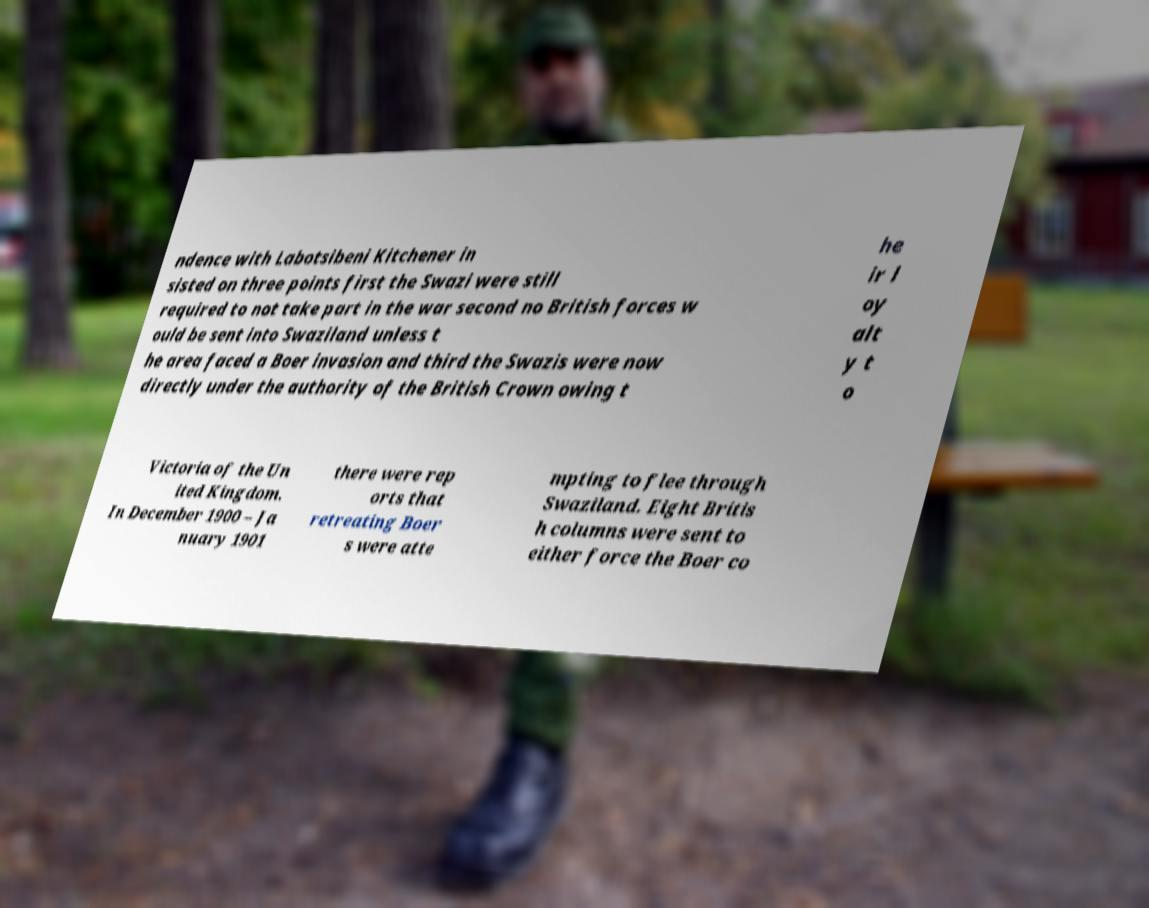There's text embedded in this image that I need extracted. Can you transcribe it verbatim? ndence with Labotsibeni Kitchener in sisted on three points first the Swazi were still required to not take part in the war second no British forces w ould be sent into Swaziland unless t he area faced a Boer invasion and third the Swazis were now directly under the authority of the British Crown owing t he ir l oy alt y t o Victoria of the Un ited Kingdom. In December 1900 – Ja nuary 1901 there were rep orts that retreating Boer s were atte mpting to flee through Swaziland. Eight Britis h columns were sent to either force the Boer co 